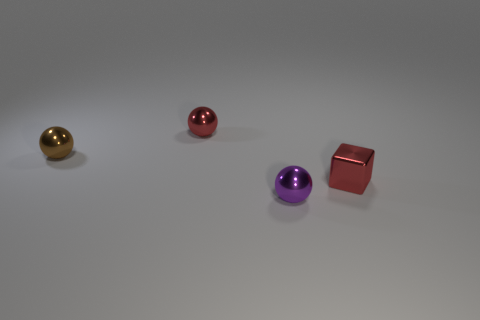Are there any other things that are the same material as the red ball?
Provide a short and direct response. Yes. Are the tiny red thing that is behind the small shiny block and the ball that is in front of the red metallic cube made of the same material?
Offer a terse response. Yes. What is the color of the metal ball that is left of the small red object that is behind the small block that is behind the purple metallic thing?
Your answer should be very brief. Brown. What number of other things are the same shape as the tiny brown metallic object?
Provide a short and direct response. 2. What number of things are metal spheres or tiny red metallic spheres to the left of the tiny purple thing?
Provide a short and direct response. 3. Are there any purple metallic cylinders of the same size as the brown thing?
Your response must be concise. No. Is the tiny brown sphere made of the same material as the purple object?
Your answer should be very brief. Yes. How many objects are brown metal objects or tiny red metal balls?
Provide a short and direct response. 2. The purple thing is what size?
Offer a very short reply. Small. Are there fewer shiny cylinders than red shiny cubes?
Give a very brief answer. Yes. 